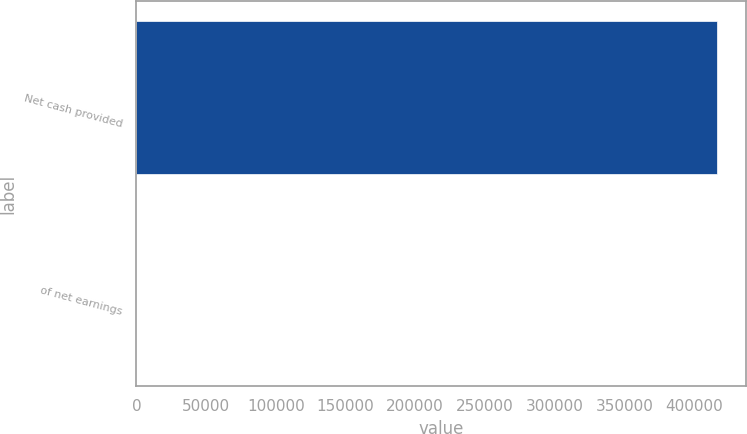Convert chart. <chart><loc_0><loc_0><loc_500><loc_500><bar_chart><fcel>Net cash provided<fcel>of net earnings<nl><fcel>416120<fcel>92.8<nl></chart> 